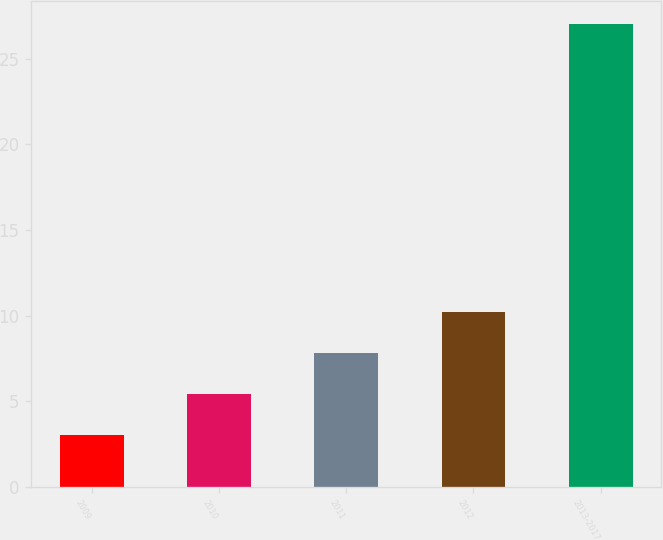<chart> <loc_0><loc_0><loc_500><loc_500><bar_chart><fcel>2009<fcel>2010<fcel>2011<fcel>2012<fcel>2013-2017<nl><fcel>3<fcel>5.4<fcel>7.8<fcel>10.2<fcel>27<nl></chart> 